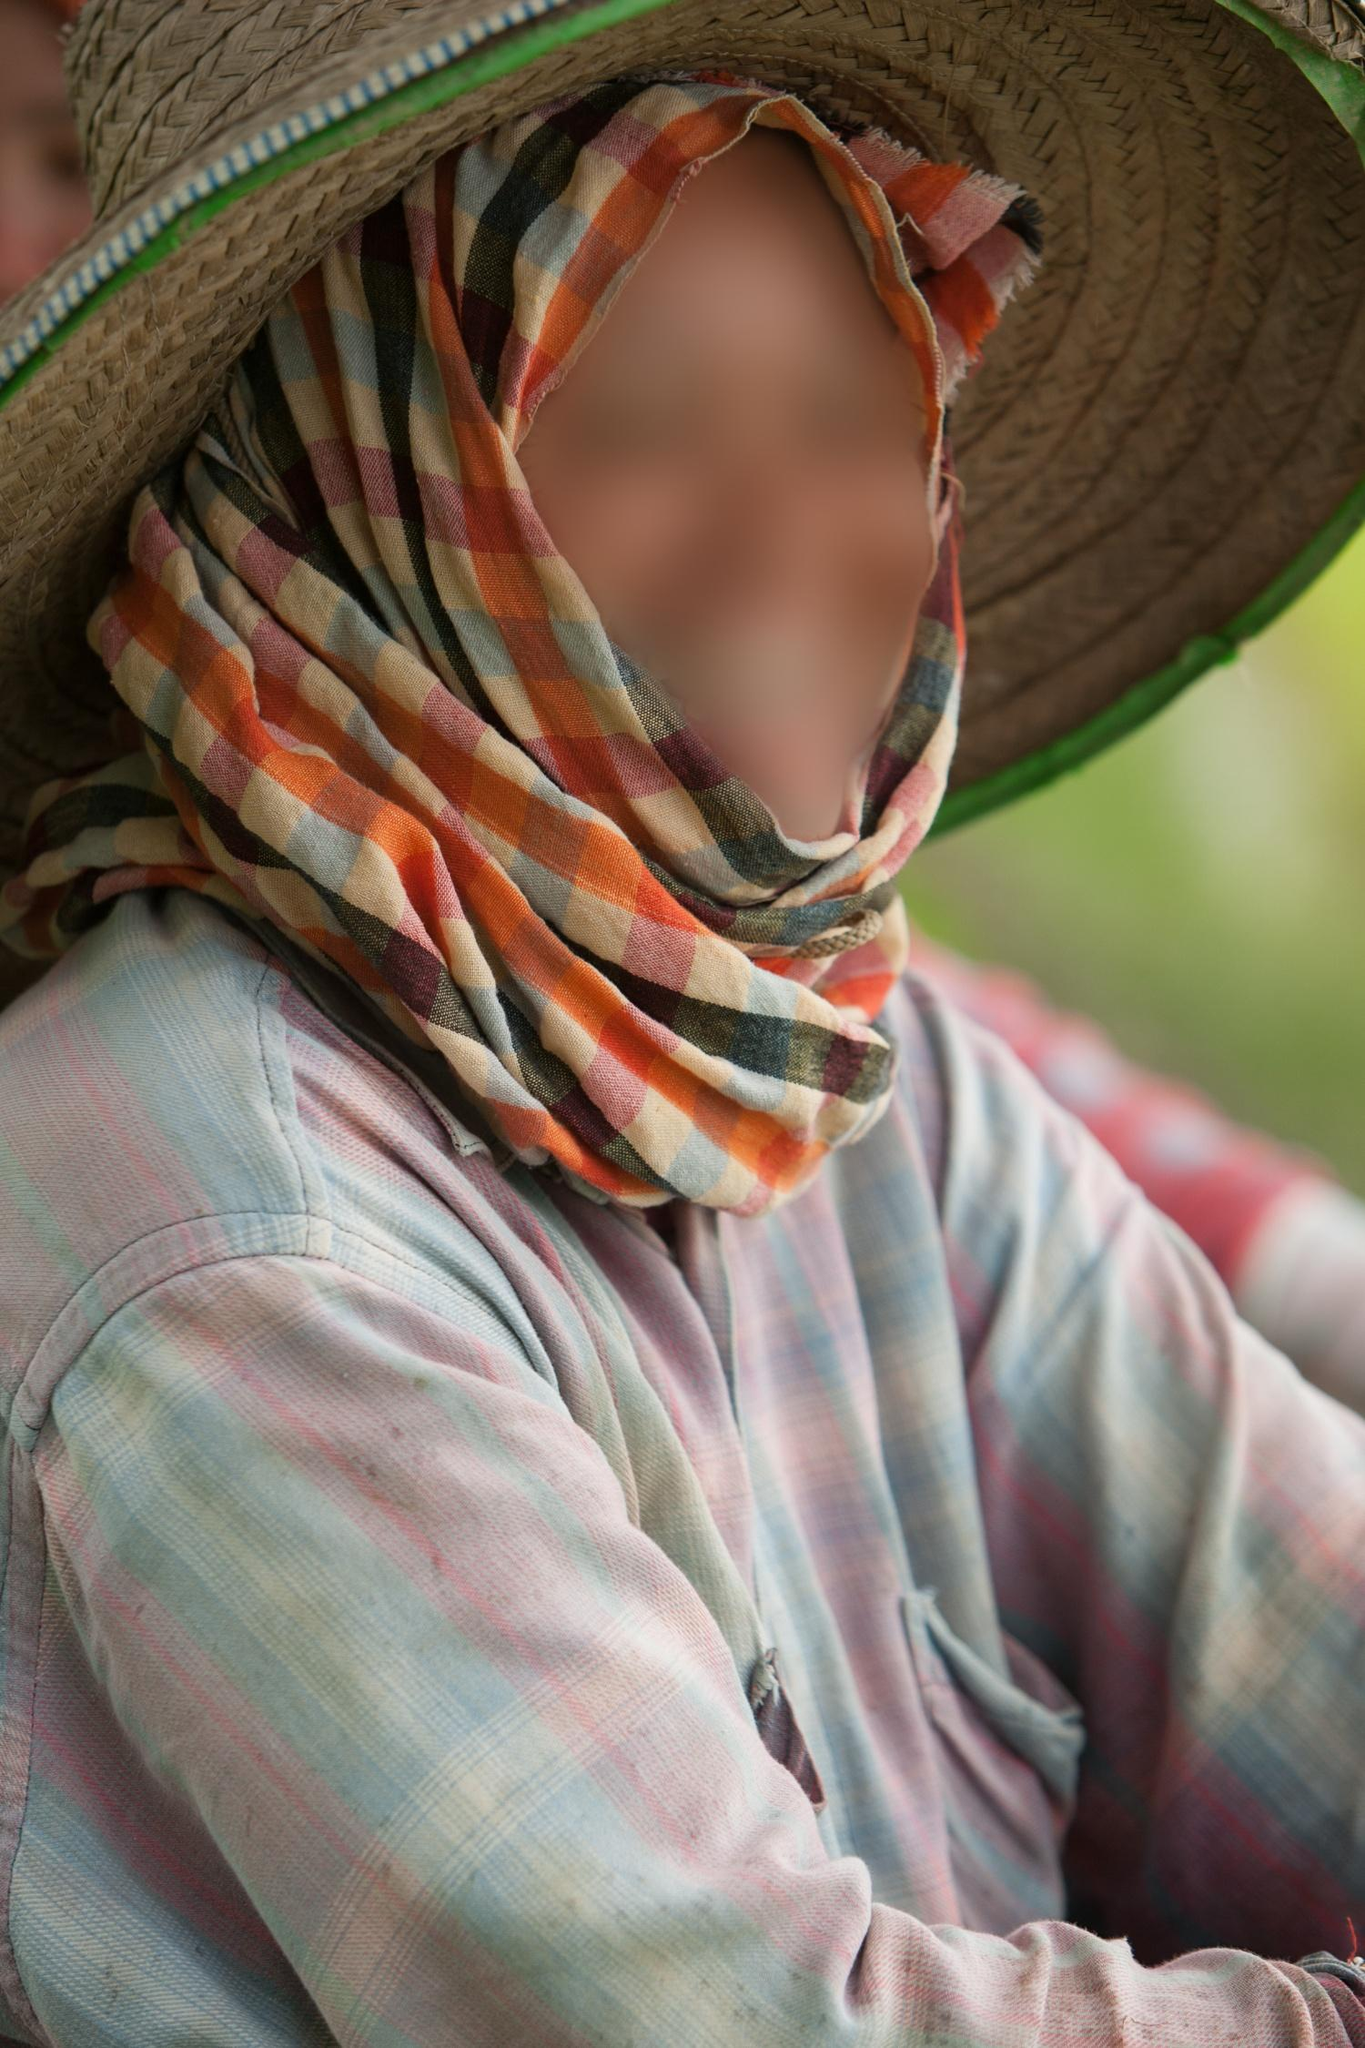Can you tell me about the accessories the person is wearing? Certainly! The individual in the image is wearing two notable accessories: a broad-brimmed straw hat and a strikingly multicolored scarf. The hat, which is woven perhaps from natural fibers, provides shade and adds a rural or pastoral flair to their appearance. The scarf, with its rich blend of colors, encircles the person's face, highlighting their eyes while adding both warmth and a splash of color to the ensemble. 